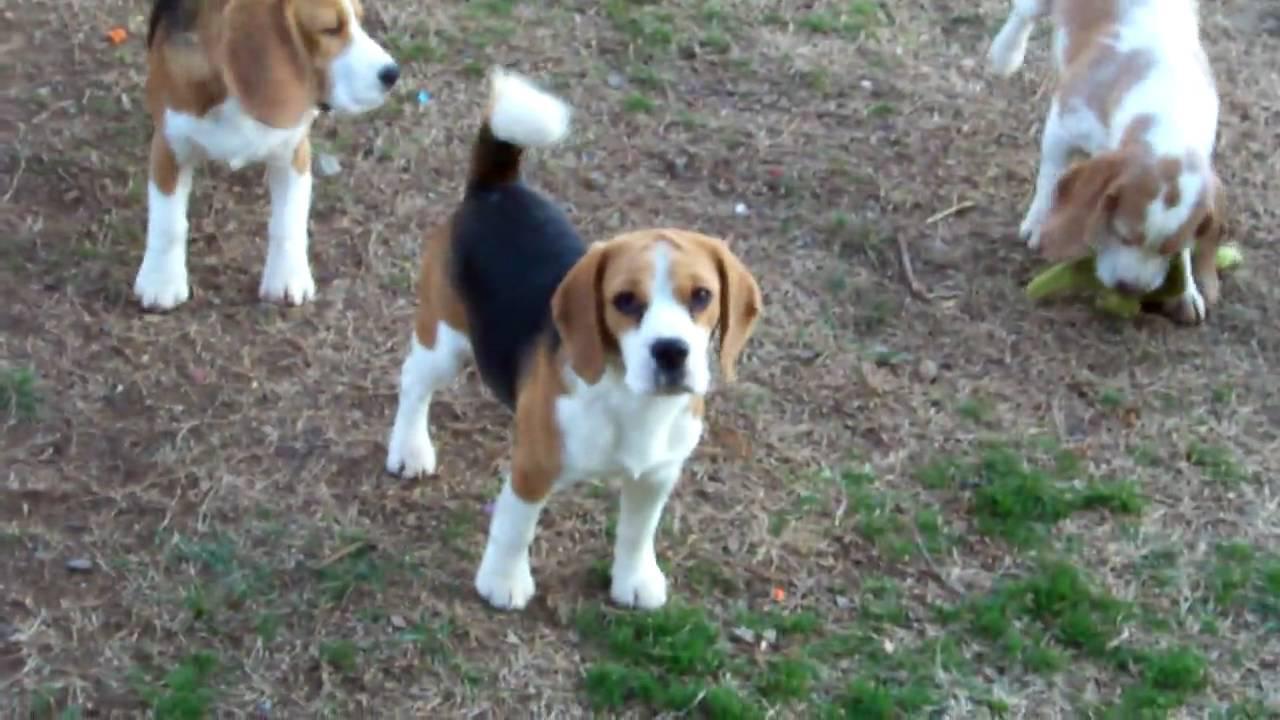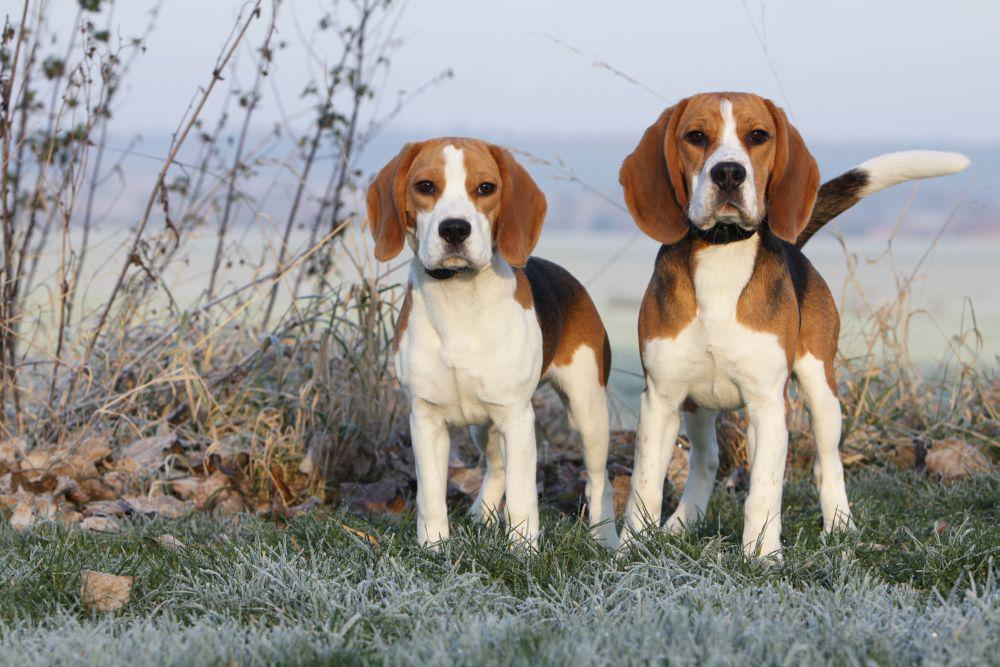The first image is the image on the left, the second image is the image on the right. Considering the images on both sides, is "Each image contains at least one beagle standing on all fours outdoors on the ground." valid? Answer yes or no. Yes. The first image is the image on the left, the second image is the image on the right. Given the left and right images, does the statement "There are exactly two dogs in total." hold true? Answer yes or no. No. 